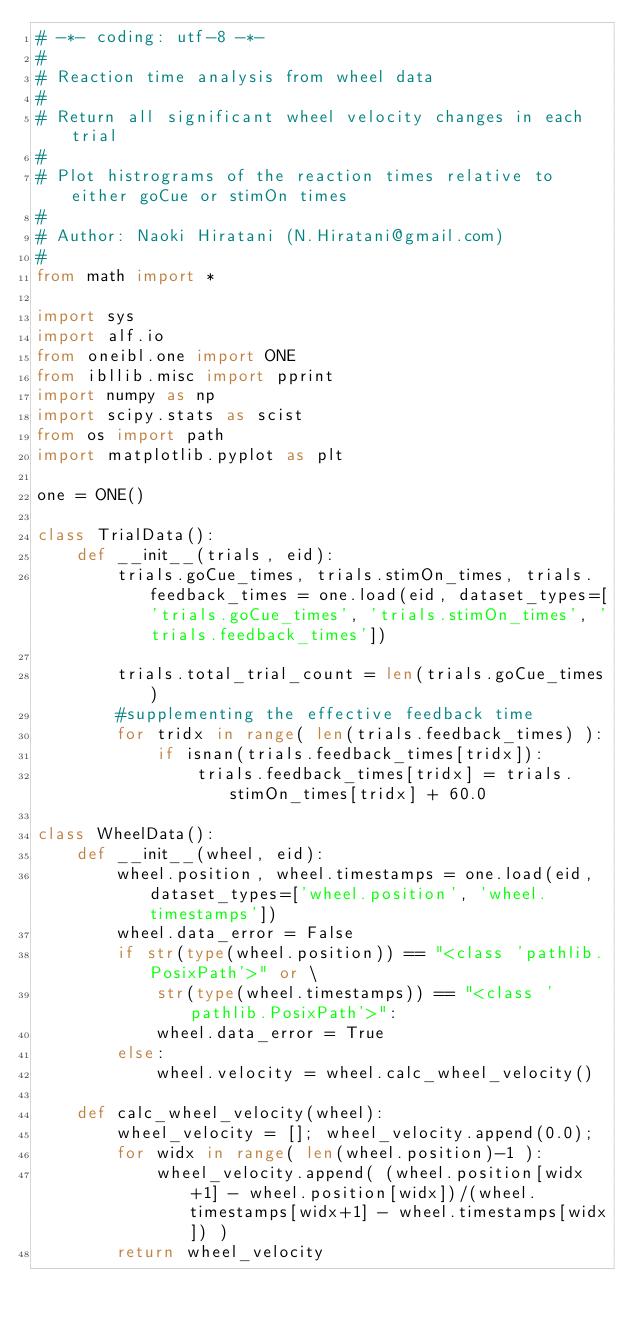<code> <loc_0><loc_0><loc_500><loc_500><_Python_># -*- coding: utf-8 -*-
#
# Reaction time analysis from wheel data
#
# Return all significant wheel velocity changes in each trial
#
# Plot histrograms of the reaction times relative to either goCue or stimOn times
#
# Author: Naoki Hiratani (N.Hiratani@gmail.com)
#
from math import *

import sys
import alf.io
from oneibl.one import ONE
from ibllib.misc import pprint
import numpy as np
import scipy.stats as scist
from os import path
import matplotlib.pyplot as plt

one = ONE()

class TrialData():
    def __init__(trials, eid):
        trials.goCue_times, trials.stimOn_times, trials.feedback_times = one.load(eid, dataset_types=['trials.goCue_times', 'trials.stimOn_times', 'trials.feedback_times'])

        trials.total_trial_count = len(trials.goCue_times)
        #supplementing the effective feedback time
        for tridx in range( len(trials.feedback_times) ):
            if isnan(trials.feedback_times[tridx]):
                trials.feedback_times[tridx] = trials.stimOn_times[tridx] + 60.0
        
class WheelData():
    def __init__(wheel, eid):
        wheel.position, wheel.timestamps = one.load(eid, dataset_types=['wheel.position', 'wheel.timestamps'])
        wheel.data_error = False
        if str(type(wheel.position)) == "<class 'pathlib.PosixPath'>" or \
            str(type(wheel.timestamps)) == "<class 'pathlib.PosixPath'>":
            wheel.data_error = True
        else:
            wheel.velocity = wheel.calc_wheel_velocity()
    
    def calc_wheel_velocity(wheel):
        wheel_velocity = []; wheel_velocity.append(0.0);
        for widx in range( len(wheel.position)-1 ):
            wheel_velocity.append( (wheel.position[widx+1] - wheel.position[widx])/(wheel.timestamps[widx+1] - wheel.timestamps[widx]) )
        return wheel_velocity
    </code> 